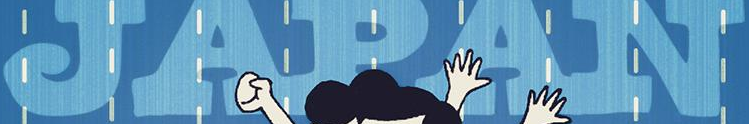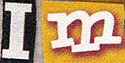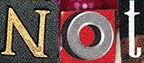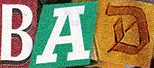Read the text from these images in sequence, separated by a semicolon. JAPAN; Im; Not; BAD 